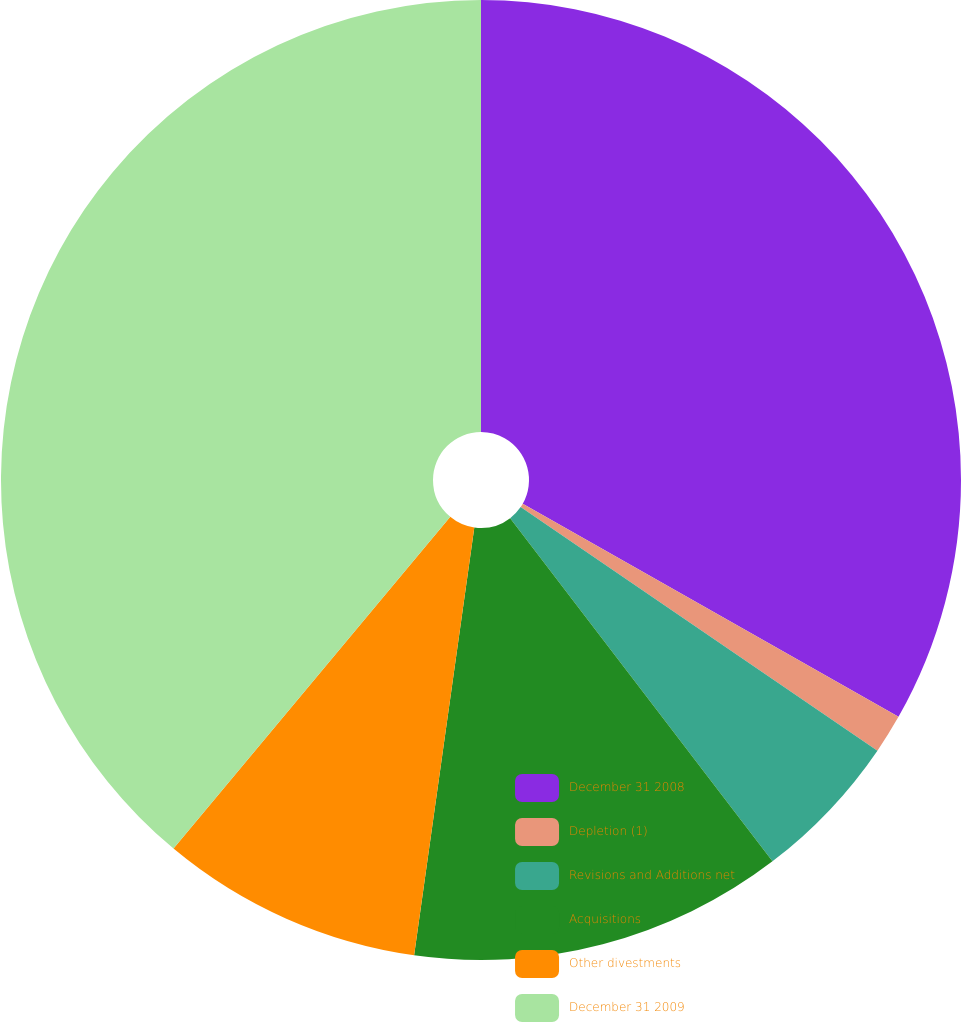<chart> <loc_0><loc_0><loc_500><loc_500><pie_chart><fcel>December 31 2008<fcel>Depletion (1)<fcel>Revisions and Additions net<fcel>Acquisitions<fcel>Other divestments<fcel>December 31 2009<nl><fcel>33.21%<fcel>1.32%<fcel>5.08%<fcel>12.61%<fcel>8.84%<fcel>38.93%<nl></chart> 